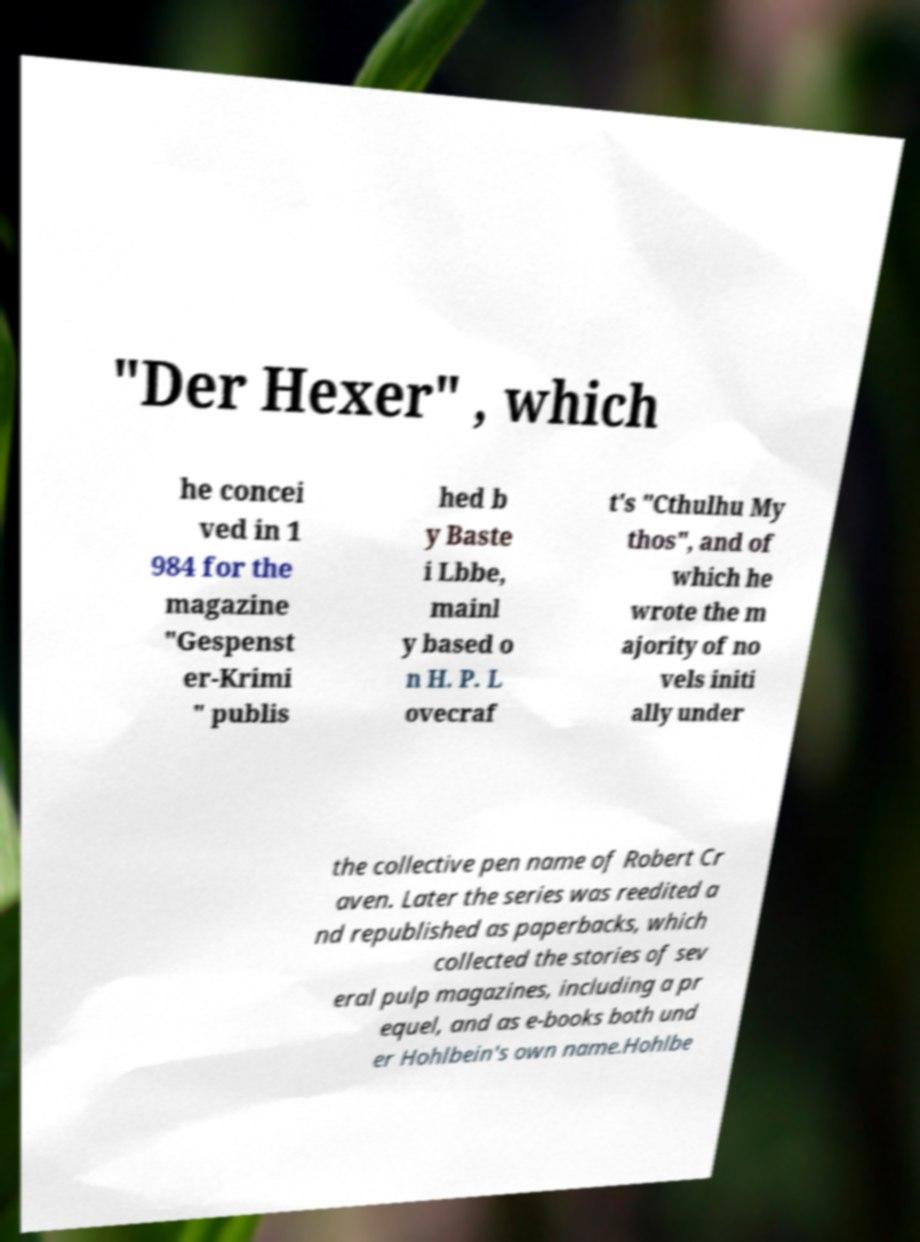What messages or text are displayed in this image? I need them in a readable, typed format. "Der Hexer" , which he concei ved in 1 984 for the magazine "Gespenst er-Krimi " publis hed b y Baste i Lbbe, mainl y based o n H. P. L ovecraf t's "Cthulhu My thos", and of which he wrote the m ajority of no vels initi ally under the collective pen name of Robert Cr aven. Later the series was reedited a nd republished as paperbacks, which collected the stories of sev eral pulp magazines, including a pr equel, and as e-books both und er Hohlbein's own name.Hohlbe 